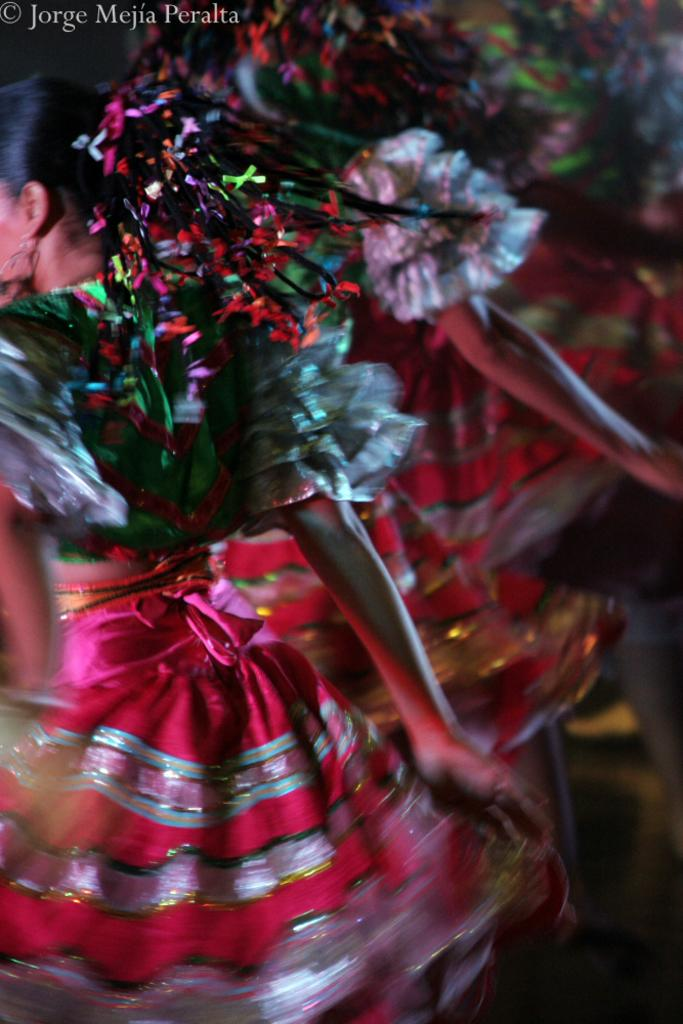Who is present in the image? There are women in the image. What are the women doing in the image? The women are dancing. Reasoning: Let' Let's think step by step in order to produce the conversation. We start by identifying the main subjects in the image, which are the women. Then, we describe their actions, which are dancing. Each question is designed to elicit a specific detail about the image that is known from the provided facts. Absurd Question/Answer: What type of engine is powering the women's dance in the image? There is no engine present in the image, and the women's dance is not powered by any engine. What type of turkey is being served at the event in the image? There is no event or turkey present in the image; it only features women dancing. 